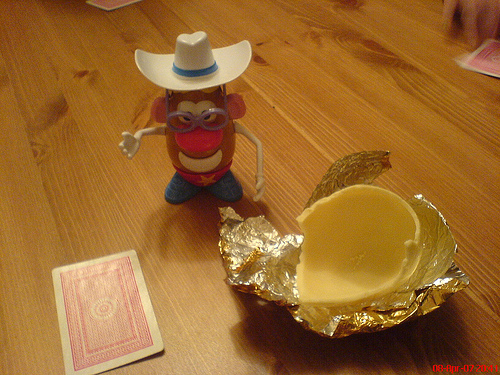<image>
Is there a hat on the mr potatoe? Yes. Looking at the image, I can see the hat is positioned on top of the mr potatoe, with the mr potatoe providing support. 